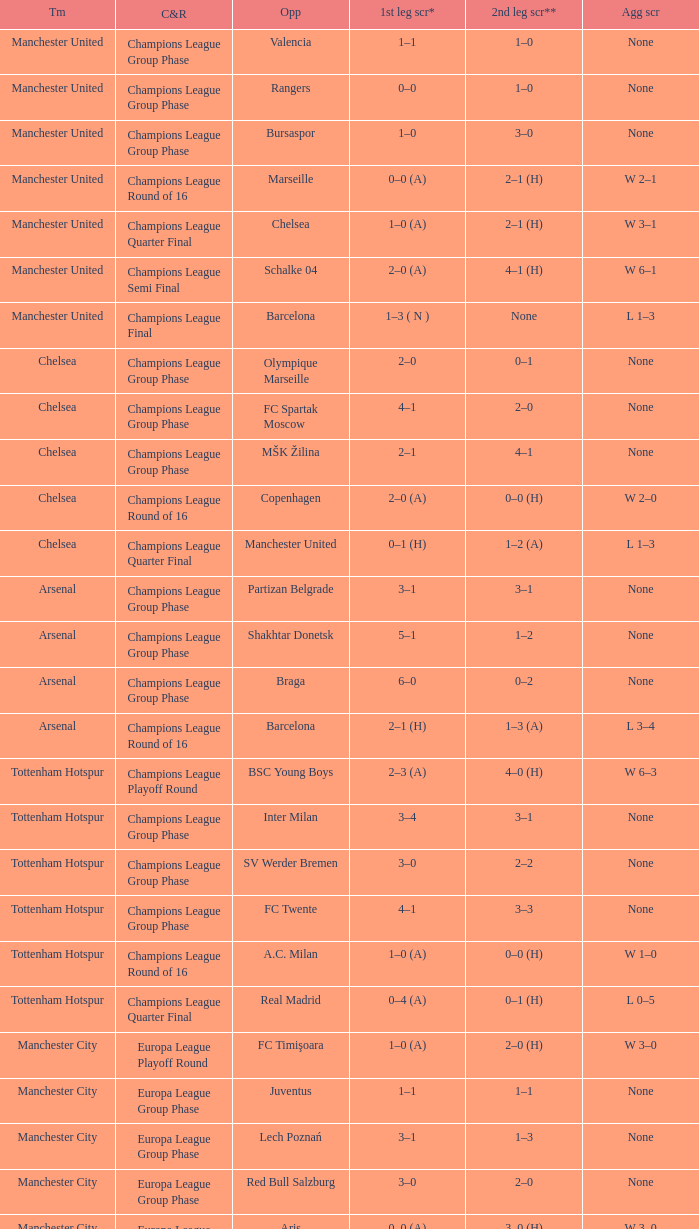How many goals did each one of the teams score in the first leg of the match between Liverpool and Trabzonspor? 1–0 (H). 